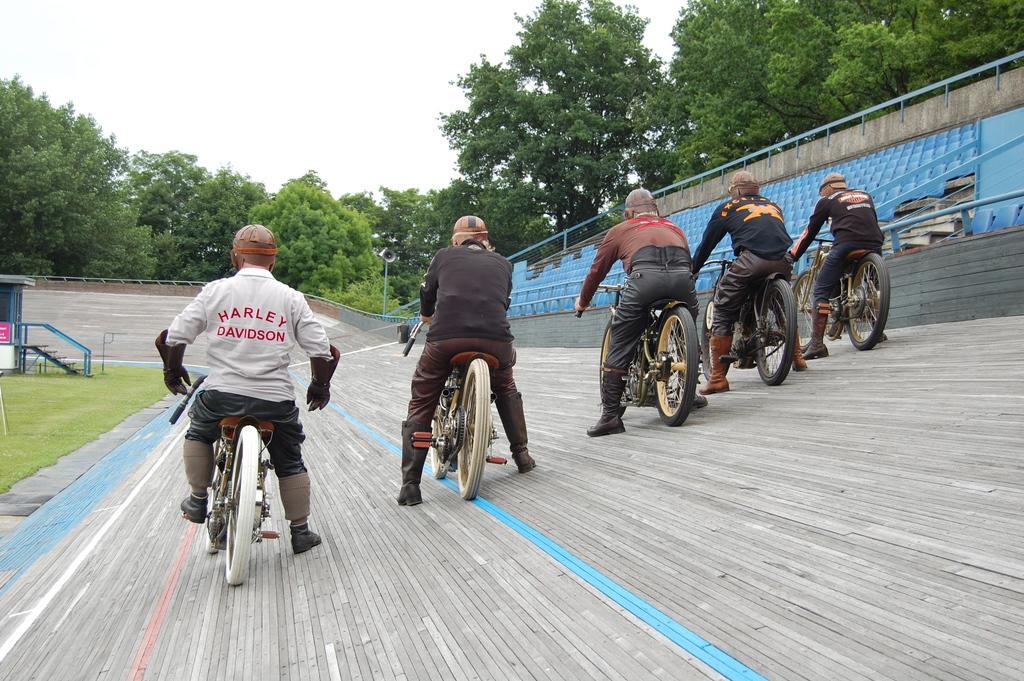Can you describe this image briefly? In this image there are group of persons riding bicycles on a wall ,and in the back ground there are chairs, iron rods, stair case , grass , a small house, trees , sky. 